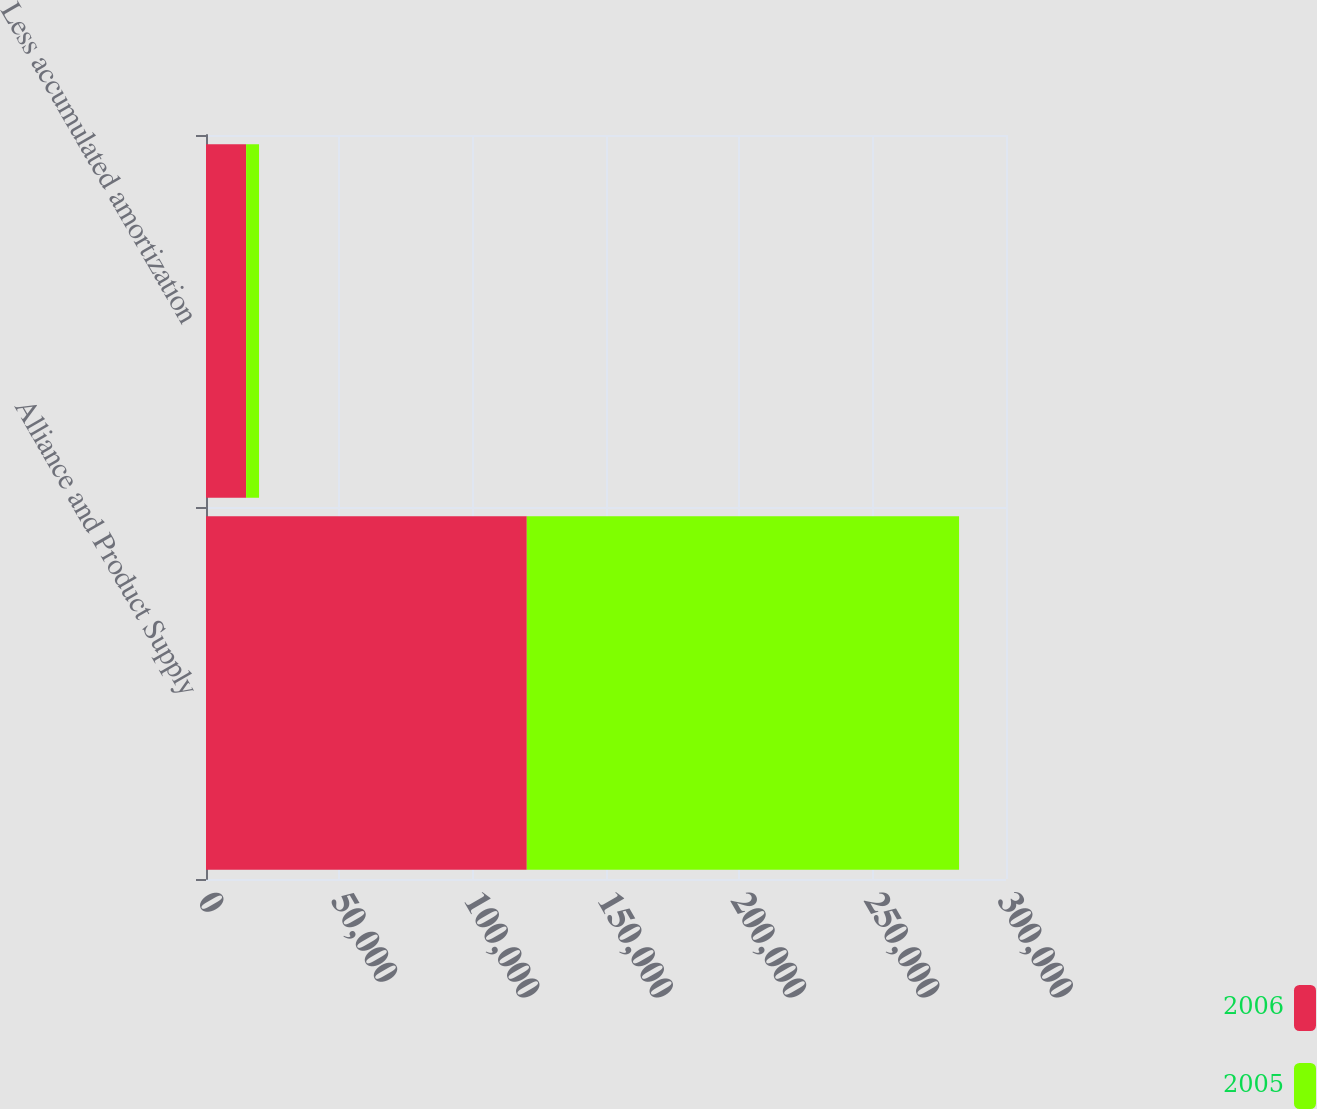Convert chart to OTSL. <chart><loc_0><loc_0><loc_500><loc_500><stacked_bar_chart><ecel><fcel>Alliance and Product Supply<fcel>Less accumulated amortization<nl><fcel>2006<fcel>120300<fcel>15037<nl><fcel>2005<fcel>162100<fcel>4856<nl></chart> 